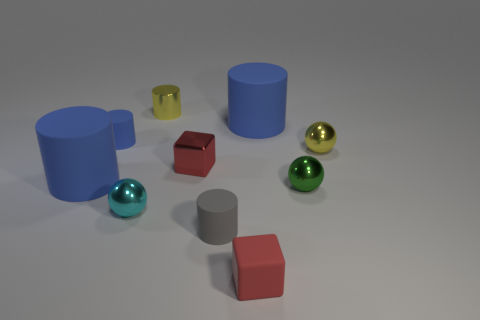Subtract all blue cylinders. How many were subtracted if there are1blue cylinders left? 2 Subtract all green balls. How many blue cylinders are left? 3 Subtract 1 cylinders. How many cylinders are left? 4 Subtract all small rubber cylinders. How many cylinders are left? 3 Subtract all yellow cylinders. How many cylinders are left? 4 Subtract all brown spheres. Subtract all gray cylinders. How many spheres are left? 3 Subtract all spheres. How many objects are left? 7 Add 7 large red matte cubes. How many large red matte cubes exist? 7 Subtract 0 green cylinders. How many objects are left? 10 Subtract all large blue metal blocks. Subtract all tiny yellow cylinders. How many objects are left? 9 